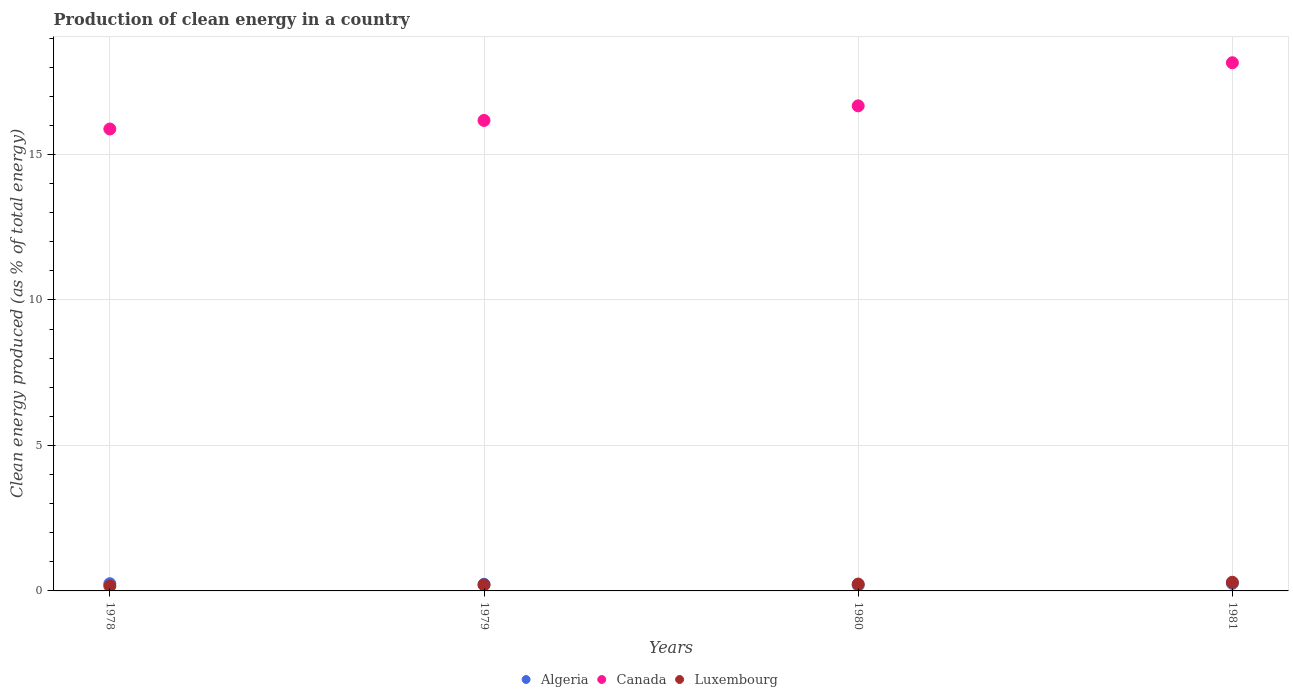Is the number of dotlines equal to the number of legend labels?
Ensure brevity in your answer.  Yes. What is the percentage of clean energy produced in Canada in 1978?
Keep it short and to the point. 15.88. Across all years, what is the maximum percentage of clean energy produced in Canada?
Provide a short and direct response. 18.15. Across all years, what is the minimum percentage of clean energy produced in Algeria?
Give a very brief answer. 0.2. In which year was the percentage of clean energy produced in Luxembourg maximum?
Your answer should be very brief. 1981. In which year was the percentage of clean energy produced in Canada minimum?
Ensure brevity in your answer.  1978. What is the total percentage of clean energy produced in Canada in the graph?
Your answer should be very brief. 66.87. What is the difference between the percentage of clean energy produced in Canada in 1980 and that in 1981?
Your answer should be compact. -1.48. What is the difference between the percentage of clean energy produced in Canada in 1981 and the percentage of clean energy produced in Luxembourg in 1978?
Your answer should be compact. 17.99. What is the average percentage of clean energy produced in Algeria per year?
Ensure brevity in your answer.  0.23. In the year 1980, what is the difference between the percentage of clean energy produced in Algeria and percentage of clean energy produced in Luxembourg?
Ensure brevity in your answer.  -0.04. What is the ratio of the percentage of clean energy produced in Canada in 1980 to that in 1981?
Ensure brevity in your answer.  0.92. Is the percentage of clean energy produced in Algeria in 1978 less than that in 1979?
Your answer should be very brief. No. What is the difference between the highest and the second highest percentage of clean energy produced in Luxembourg?
Offer a very short reply. 0.06. What is the difference between the highest and the lowest percentage of clean energy produced in Canada?
Your answer should be compact. 2.28. In how many years, is the percentage of clean energy produced in Algeria greater than the average percentage of clean energy produced in Algeria taken over all years?
Keep it short and to the point. 2. Does the percentage of clean energy produced in Algeria monotonically increase over the years?
Offer a very short reply. No. Is the percentage of clean energy produced in Algeria strictly greater than the percentage of clean energy produced in Luxembourg over the years?
Make the answer very short. No. Is the percentage of clean energy produced in Algeria strictly less than the percentage of clean energy produced in Luxembourg over the years?
Provide a short and direct response. No. How many dotlines are there?
Provide a short and direct response. 3. How many years are there in the graph?
Make the answer very short. 4. Does the graph contain any zero values?
Your response must be concise. No. Where does the legend appear in the graph?
Ensure brevity in your answer.  Bottom center. How are the legend labels stacked?
Your answer should be very brief. Horizontal. What is the title of the graph?
Your answer should be compact. Production of clean energy in a country. What is the label or title of the X-axis?
Your response must be concise. Years. What is the label or title of the Y-axis?
Provide a short and direct response. Clean energy produced (as % of total energy). What is the Clean energy produced (as % of total energy) of Algeria in 1978?
Make the answer very short. 0.25. What is the Clean energy produced (as % of total energy) in Canada in 1978?
Offer a very short reply. 15.88. What is the Clean energy produced (as % of total energy) of Luxembourg in 1978?
Give a very brief answer. 0.17. What is the Clean energy produced (as % of total energy) in Algeria in 1979?
Provide a succinct answer. 0.23. What is the Clean energy produced (as % of total energy) of Canada in 1979?
Provide a succinct answer. 16.17. What is the Clean energy produced (as % of total energy) of Luxembourg in 1979?
Keep it short and to the point. 0.21. What is the Clean energy produced (as % of total energy) of Algeria in 1980?
Provide a succinct answer. 0.2. What is the Clean energy produced (as % of total energy) of Canada in 1980?
Offer a very short reply. 16.67. What is the Clean energy produced (as % of total energy) in Luxembourg in 1980?
Your answer should be very brief. 0.24. What is the Clean energy produced (as % of total energy) of Algeria in 1981?
Give a very brief answer. 0.26. What is the Clean energy produced (as % of total energy) of Canada in 1981?
Your answer should be compact. 18.15. What is the Clean energy produced (as % of total energy) in Luxembourg in 1981?
Make the answer very short. 0.3. Across all years, what is the maximum Clean energy produced (as % of total energy) in Algeria?
Provide a succinct answer. 0.26. Across all years, what is the maximum Clean energy produced (as % of total energy) of Canada?
Your response must be concise. 18.15. Across all years, what is the maximum Clean energy produced (as % of total energy) in Luxembourg?
Offer a very short reply. 0.3. Across all years, what is the minimum Clean energy produced (as % of total energy) in Algeria?
Provide a succinct answer. 0.2. Across all years, what is the minimum Clean energy produced (as % of total energy) in Canada?
Ensure brevity in your answer.  15.88. Across all years, what is the minimum Clean energy produced (as % of total energy) in Luxembourg?
Ensure brevity in your answer.  0.17. What is the total Clean energy produced (as % of total energy) in Algeria in the graph?
Ensure brevity in your answer.  0.93. What is the total Clean energy produced (as % of total energy) of Canada in the graph?
Ensure brevity in your answer.  66.87. What is the total Clean energy produced (as % of total energy) in Luxembourg in the graph?
Your response must be concise. 0.91. What is the difference between the Clean energy produced (as % of total energy) of Algeria in 1978 and that in 1979?
Your answer should be compact. 0.02. What is the difference between the Clean energy produced (as % of total energy) in Canada in 1978 and that in 1979?
Provide a short and direct response. -0.29. What is the difference between the Clean energy produced (as % of total energy) of Luxembourg in 1978 and that in 1979?
Your response must be concise. -0.04. What is the difference between the Clean energy produced (as % of total energy) in Algeria in 1978 and that in 1980?
Offer a terse response. 0.05. What is the difference between the Clean energy produced (as % of total energy) in Canada in 1978 and that in 1980?
Make the answer very short. -0.8. What is the difference between the Clean energy produced (as % of total energy) in Luxembourg in 1978 and that in 1980?
Your answer should be compact. -0.07. What is the difference between the Clean energy produced (as % of total energy) of Algeria in 1978 and that in 1981?
Provide a succinct answer. -0.01. What is the difference between the Clean energy produced (as % of total energy) of Canada in 1978 and that in 1981?
Your answer should be very brief. -2.28. What is the difference between the Clean energy produced (as % of total energy) in Luxembourg in 1978 and that in 1981?
Offer a very short reply. -0.13. What is the difference between the Clean energy produced (as % of total energy) in Algeria in 1979 and that in 1980?
Provide a succinct answer. 0.03. What is the difference between the Clean energy produced (as % of total energy) of Canada in 1979 and that in 1980?
Your answer should be very brief. -0.5. What is the difference between the Clean energy produced (as % of total energy) in Luxembourg in 1979 and that in 1980?
Make the answer very short. -0.03. What is the difference between the Clean energy produced (as % of total energy) of Algeria in 1979 and that in 1981?
Provide a succinct answer. -0.03. What is the difference between the Clean energy produced (as % of total energy) in Canada in 1979 and that in 1981?
Provide a succinct answer. -1.98. What is the difference between the Clean energy produced (as % of total energy) of Luxembourg in 1979 and that in 1981?
Give a very brief answer. -0.09. What is the difference between the Clean energy produced (as % of total energy) of Algeria in 1980 and that in 1981?
Your answer should be compact. -0.06. What is the difference between the Clean energy produced (as % of total energy) of Canada in 1980 and that in 1981?
Keep it short and to the point. -1.48. What is the difference between the Clean energy produced (as % of total energy) of Luxembourg in 1980 and that in 1981?
Offer a terse response. -0.06. What is the difference between the Clean energy produced (as % of total energy) of Algeria in 1978 and the Clean energy produced (as % of total energy) of Canada in 1979?
Give a very brief answer. -15.92. What is the difference between the Clean energy produced (as % of total energy) of Algeria in 1978 and the Clean energy produced (as % of total energy) of Luxembourg in 1979?
Offer a terse response. 0.04. What is the difference between the Clean energy produced (as % of total energy) in Canada in 1978 and the Clean energy produced (as % of total energy) in Luxembourg in 1979?
Offer a very short reply. 15.67. What is the difference between the Clean energy produced (as % of total energy) of Algeria in 1978 and the Clean energy produced (as % of total energy) of Canada in 1980?
Keep it short and to the point. -16.42. What is the difference between the Clean energy produced (as % of total energy) of Algeria in 1978 and the Clean energy produced (as % of total energy) of Luxembourg in 1980?
Your answer should be very brief. 0.01. What is the difference between the Clean energy produced (as % of total energy) of Canada in 1978 and the Clean energy produced (as % of total energy) of Luxembourg in 1980?
Keep it short and to the point. 15.64. What is the difference between the Clean energy produced (as % of total energy) of Algeria in 1978 and the Clean energy produced (as % of total energy) of Canada in 1981?
Keep it short and to the point. -17.91. What is the difference between the Clean energy produced (as % of total energy) in Algeria in 1978 and the Clean energy produced (as % of total energy) in Luxembourg in 1981?
Make the answer very short. -0.05. What is the difference between the Clean energy produced (as % of total energy) of Canada in 1978 and the Clean energy produced (as % of total energy) of Luxembourg in 1981?
Make the answer very short. 15.58. What is the difference between the Clean energy produced (as % of total energy) in Algeria in 1979 and the Clean energy produced (as % of total energy) in Canada in 1980?
Your answer should be very brief. -16.44. What is the difference between the Clean energy produced (as % of total energy) in Algeria in 1979 and the Clean energy produced (as % of total energy) in Luxembourg in 1980?
Ensure brevity in your answer.  -0.01. What is the difference between the Clean energy produced (as % of total energy) of Canada in 1979 and the Clean energy produced (as % of total energy) of Luxembourg in 1980?
Give a very brief answer. 15.93. What is the difference between the Clean energy produced (as % of total energy) of Algeria in 1979 and the Clean energy produced (as % of total energy) of Canada in 1981?
Give a very brief answer. -17.93. What is the difference between the Clean energy produced (as % of total energy) of Algeria in 1979 and the Clean energy produced (as % of total energy) of Luxembourg in 1981?
Your response must be concise. -0.07. What is the difference between the Clean energy produced (as % of total energy) in Canada in 1979 and the Clean energy produced (as % of total energy) in Luxembourg in 1981?
Offer a very short reply. 15.87. What is the difference between the Clean energy produced (as % of total energy) of Algeria in 1980 and the Clean energy produced (as % of total energy) of Canada in 1981?
Keep it short and to the point. -17.96. What is the difference between the Clean energy produced (as % of total energy) in Algeria in 1980 and the Clean energy produced (as % of total energy) in Luxembourg in 1981?
Your response must be concise. -0.1. What is the difference between the Clean energy produced (as % of total energy) of Canada in 1980 and the Clean energy produced (as % of total energy) of Luxembourg in 1981?
Provide a short and direct response. 16.37. What is the average Clean energy produced (as % of total energy) of Algeria per year?
Give a very brief answer. 0.23. What is the average Clean energy produced (as % of total energy) of Canada per year?
Offer a terse response. 16.72. What is the average Clean energy produced (as % of total energy) in Luxembourg per year?
Ensure brevity in your answer.  0.23. In the year 1978, what is the difference between the Clean energy produced (as % of total energy) in Algeria and Clean energy produced (as % of total energy) in Canada?
Provide a short and direct response. -15.63. In the year 1978, what is the difference between the Clean energy produced (as % of total energy) in Algeria and Clean energy produced (as % of total energy) in Luxembourg?
Give a very brief answer. 0.08. In the year 1978, what is the difference between the Clean energy produced (as % of total energy) of Canada and Clean energy produced (as % of total energy) of Luxembourg?
Ensure brevity in your answer.  15.71. In the year 1979, what is the difference between the Clean energy produced (as % of total energy) of Algeria and Clean energy produced (as % of total energy) of Canada?
Give a very brief answer. -15.94. In the year 1979, what is the difference between the Clean energy produced (as % of total energy) in Algeria and Clean energy produced (as % of total energy) in Luxembourg?
Make the answer very short. 0.02. In the year 1979, what is the difference between the Clean energy produced (as % of total energy) in Canada and Clean energy produced (as % of total energy) in Luxembourg?
Keep it short and to the point. 15.96. In the year 1980, what is the difference between the Clean energy produced (as % of total energy) in Algeria and Clean energy produced (as % of total energy) in Canada?
Make the answer very short. -16.48. In the year 1980, what is the difference between the Clean energy produced (as % of total energy) of Algeria and Clean energy produced (as % of total energy) of Luxembourg?
Your answer should be very brief. -0.04. In the year 1980, what is the difference between the Clean energy produced (as % of total energy) of Canada and Clean energy produced (as % of total energy) of Luxembourg?
Give a very brief answer. 16.44. In the year 1981, what is the difference between the Clean energy produced (as % of total energy) in Algeria and Clean energy produced (as % of total energy) in Canada?
Your answer should be very brief. -17.9. In the year 1981, what is the difference between the Clean energy produced (as % of total energy) in Algeria and Clean energy produced (as % of total energy) in Luxembourg?
Give a very brief answer. -0.04. In the year 1981, what is the difference between the Clean energy produced (as % of total energy) in Canada and Clean energy produced (as % of total energy) in Luxembourg?
Ensure brevity in your answer.  17.86. What is the ratio of the Clean energy produced (as % of total energy) of Algeria in 1978 to that in 1979?
Your answer should be very brief. 1.09. What is the ratio of the Clean energy produced (as % of total energy) of Canada in 1978 to that in 1979?
Keep it short and to the point. 0.98. What is the ratio of the Clean energy produced (as % of total energy) of Luxembourg in 1978 to that in 1979?
Your response must be concise. 0.82. What is the ratio of the Clean energy produced (as % of total energy) of Algeria in 1978 to that in 1980?
Provide a short and direct response. 1.26. What is the ratio of the Clean energy produced (as % of total energy) in Canada in 1978 to that in 1980?
Provide a short and direct response. 0.95. What is the ratio of the Clean energy produced (as % of total energy) in Canada in 1978 to that in 1981?
Offer a terse response. 0.87. What is the ratio of the Clean energy produced (as % of total energy) of Luxembourg in 1978 to that in 1981?
Ensure brevity in your answer.  0.57. What is the ratio of the Clean energy produced (as % of total energy) of Algeria in 1979 to that in 1980?
Offer a terse response. 1.15. What is the ratio of the Clean energy produced (as % of total energy) in Canada in 1979 to that in 1980?
Offer a very short reply. 0.97. What is the ratio of the Clean energy produced (as % of total energy) of Luxembourg in 1979 to that in 1980?
Give a very brief answer. 0.87. What is the ratio of the Clean energy produced (as % of total energy) in Algeria in 1979 to that in 1981?
Your answer should be very brief. 0.88. What is the ratio of the Clean energy produced (as % of total energy) of Canada in 1979 to that in 1981?
Provide a short and direct response. 0.89. What is the ratio of the Clean energy produced (as % of total energy) in Luxembourg in 1979 to that in 1981?
Your response must be concise. 0.69. What is the ratio of the Clean energy produced (as % of total energy) of Algeria in 1980 to that in 1981?
Offer a very short reply. 0.76. What is the ratio of the Clean energy produced (as % of total energy) of Canada in 1980 to that in 1981?
Your answer should be very brief. 0.92. What is the ratio of the Clean energy produced (as % of total energy) of Luxembourg in 1980 to that in 1981?
Your answer should be very brief. 0.79. What is the difference between the highest and the second highest Clean energy produced (as % of total energy) of Algeria?
Ensure brevity in your answer.  0.01. What is the difference between the highest and the second highest Clean energy produced (as % of total energy) of Canada?
Your response must be concise. 1.48. What is the difference between the highest and the second highest Clean energy produced (as % of total energy) in Luxembourg?
Offer a very short reply. 0.06. What is the difference between the highest and the lowest Clean energy produced (as % of total energy) of Algeria?
Provide a short and direct response. 0.06. What is the difference between the highest and the lowest Clean energy produced (as % of total energy) of Canada?
Offer a terse response. 2.28. What is the difference between the highest and the lowest Clean energy produced (as % of total energy) of Luxembourg?
Ensure brevity in your answer.  0.13. 